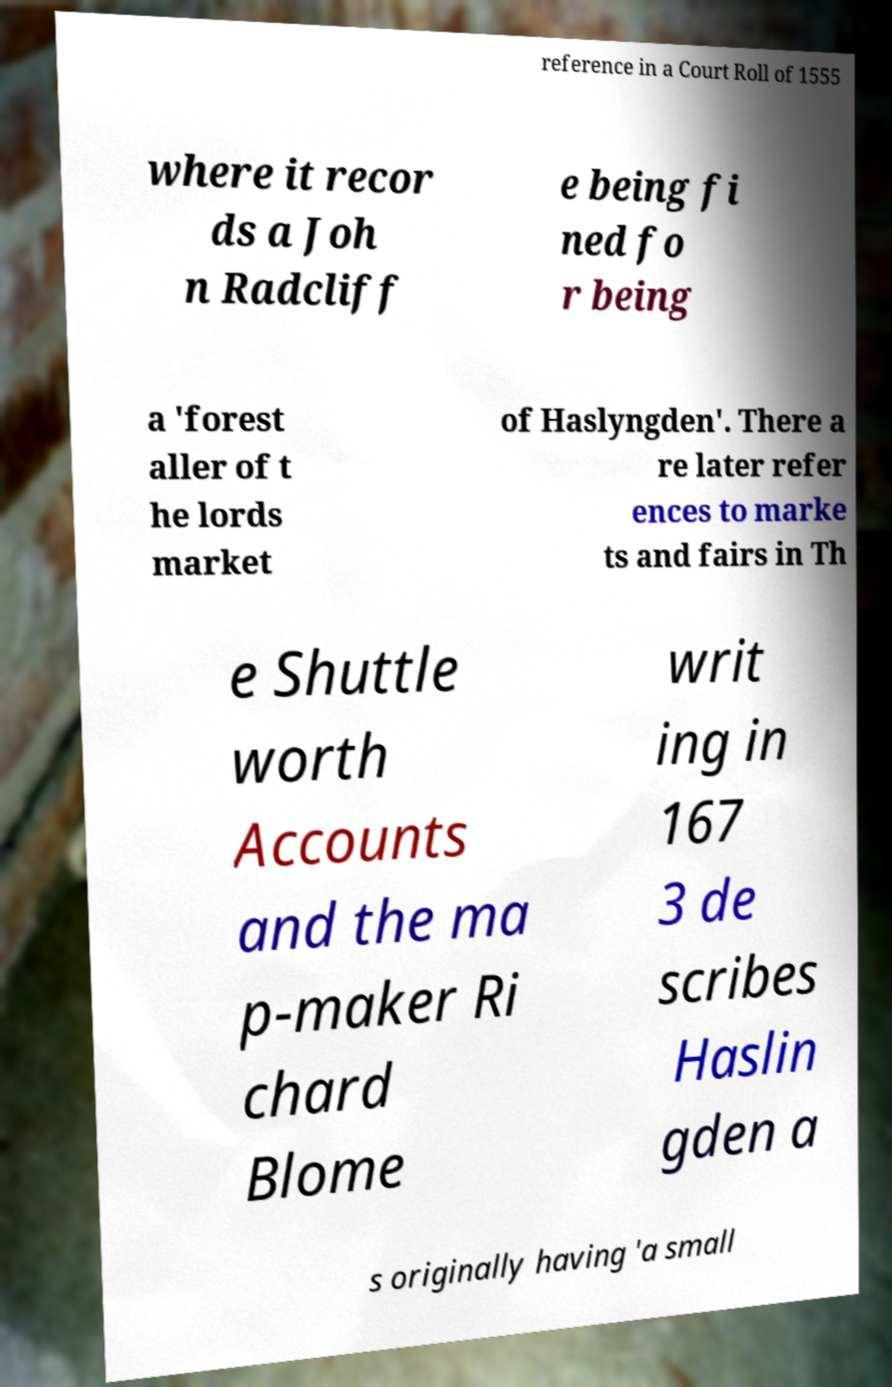There's text embedded in this image that I need extracted. Can you transcribe it verbatim? reference in a Court Roll of 1555 where it recor ds a Joh n Radcliff e being fi ned fo r being a 'forest aller of t he lords market of Haslyngden'. There a re later refer ences to marke ts and fairs in Th e Shuttle worth Accounts and the ma p-maker Ri chard Blome writ ing in 167 3 de scribes Haslin gden a s originally having 'a small 